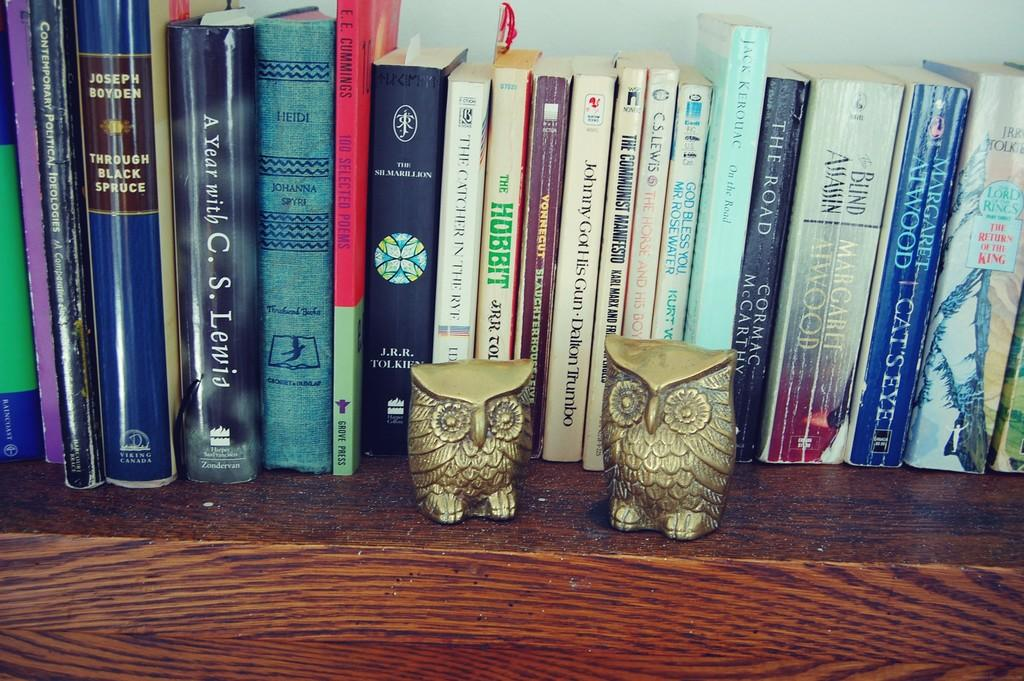What color are the objects in the front of the image? The objects in the front of the image are golden in color. What can be seen in the background of the image? There are books in the background of the image. What type of cake is being served in the image? There is no cake present in the image. What is the plot of the story being told by the books in the image? The image does not depict a story being told by the books, so there is no plot to describe. 